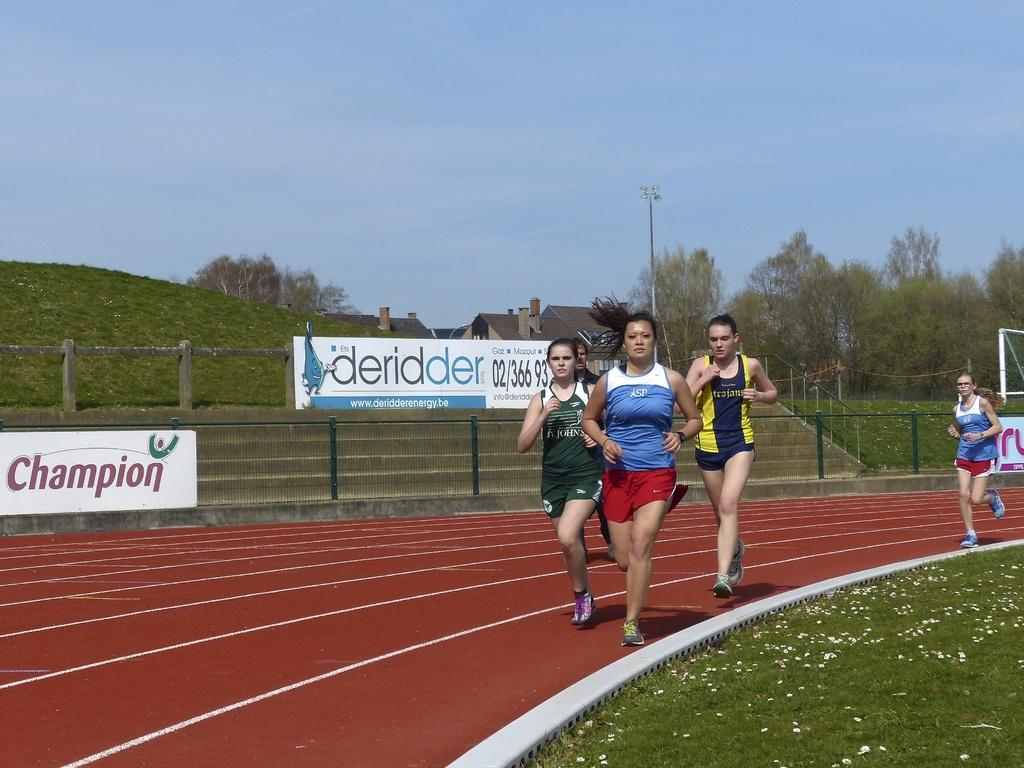What is the main subject of the image? The main subject of the image is a group of girls. What are the girls doing in the image? The girls are running on a runway in the image. What can be seen in the background of the image? There is a fence with banners, a building, trees, and a small mountain with grass in the image. What type of cork can be seen on the ground near the girls in the image? There is no cork present on the ground near the girls in the image. Can you tell me how many chickens are running with the girls in the image? There are no chickens present in the image; only the group of girls is visible. 